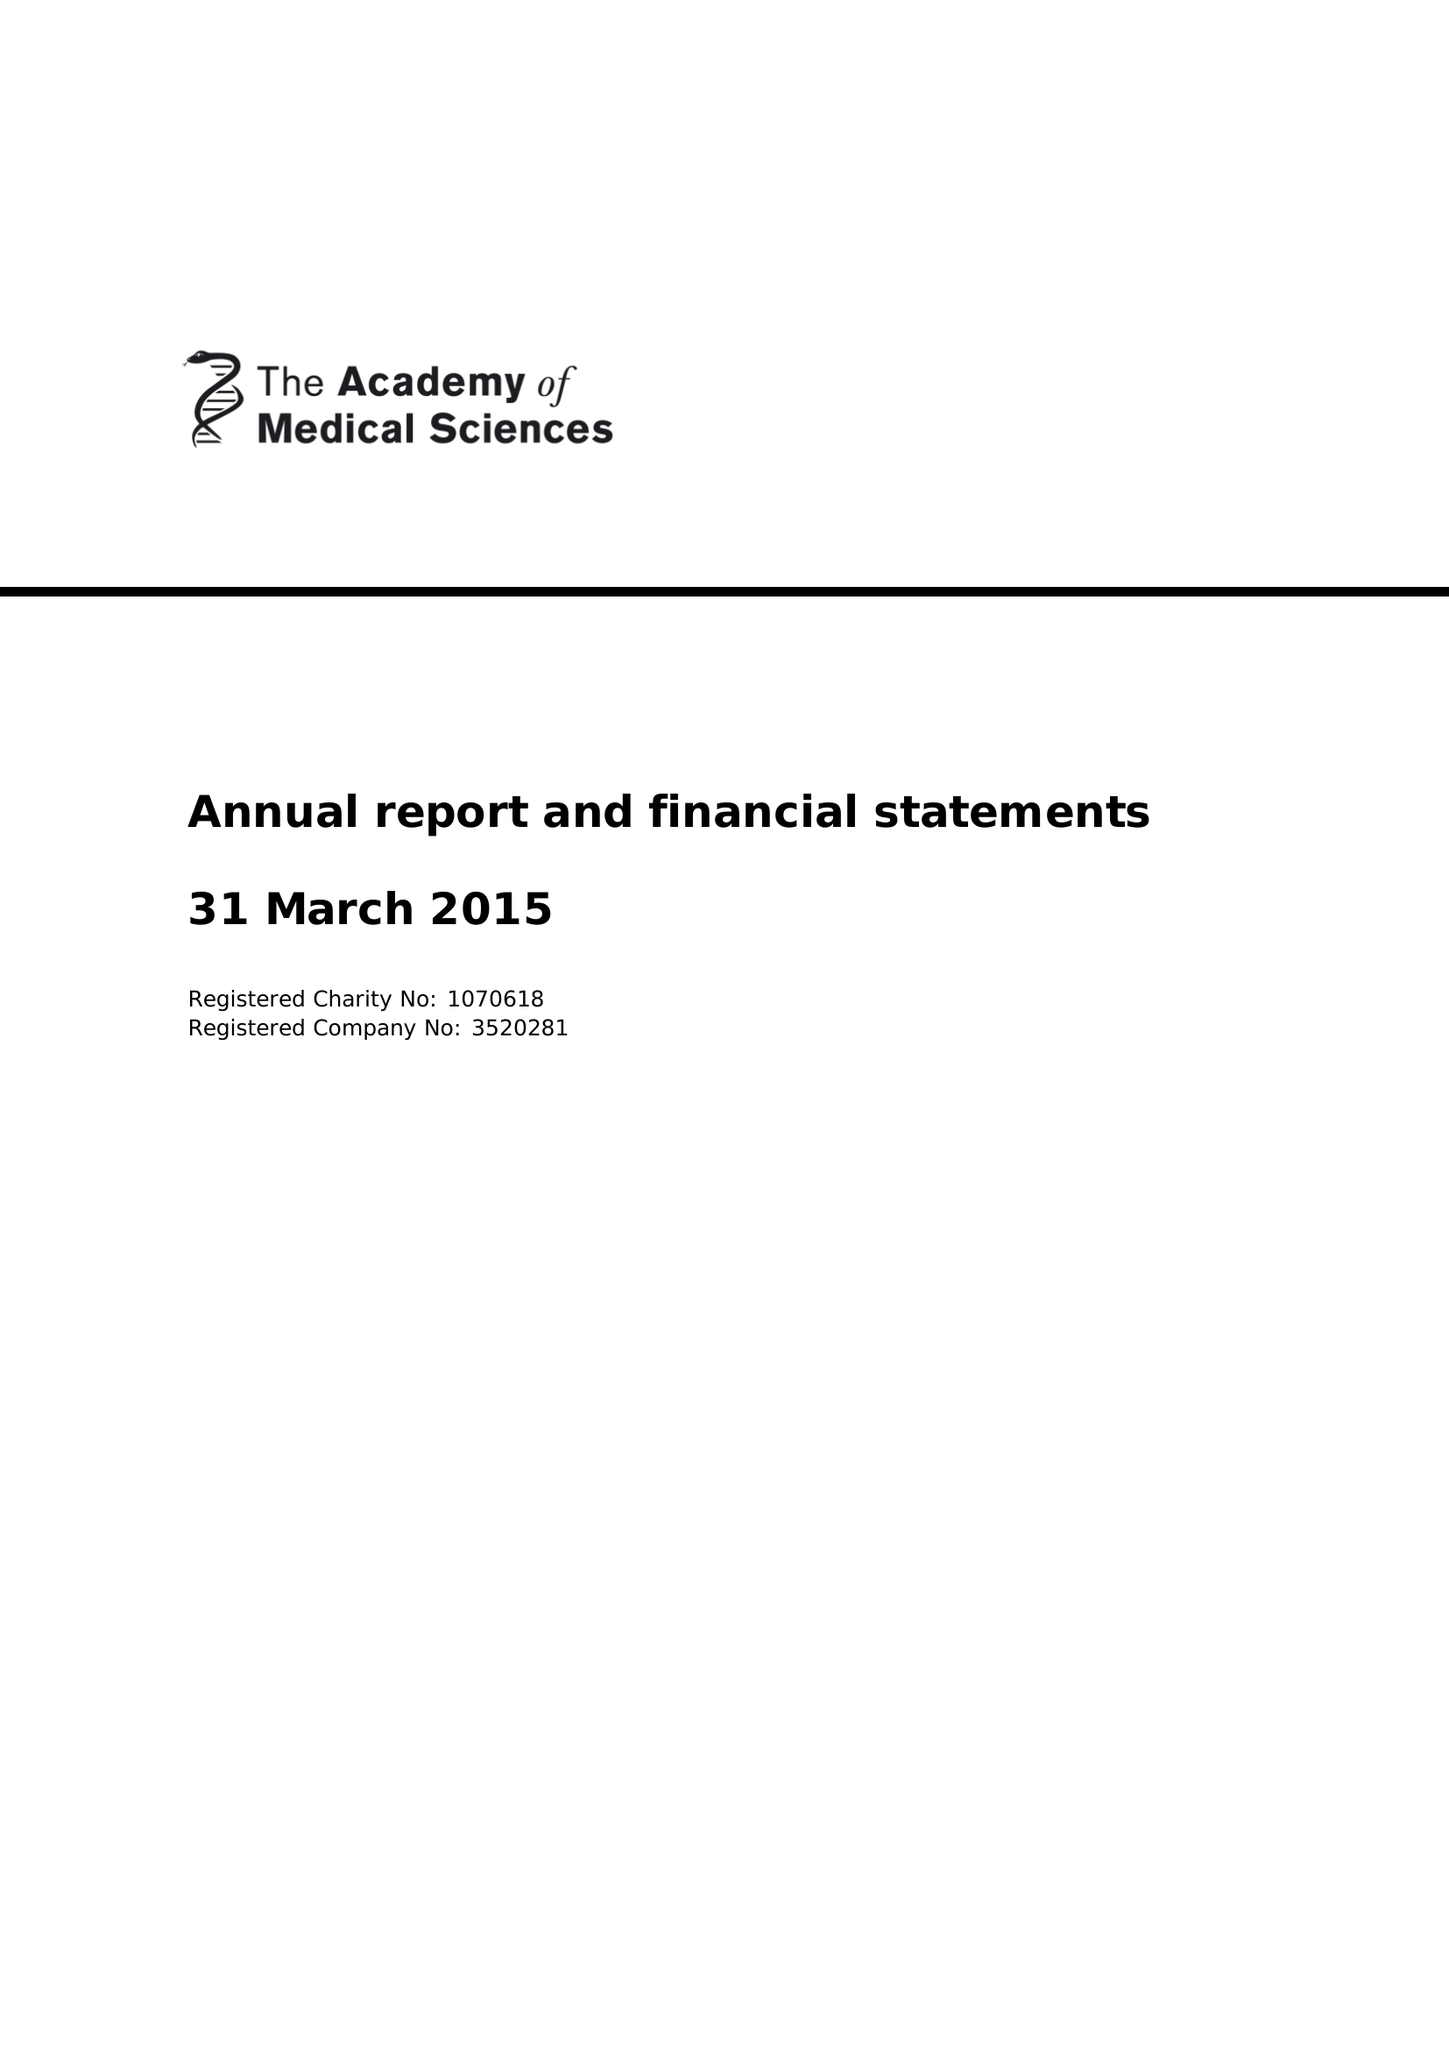What is the value for the report_date?
Answer the question using a single word or phrase. 2015-03-31 